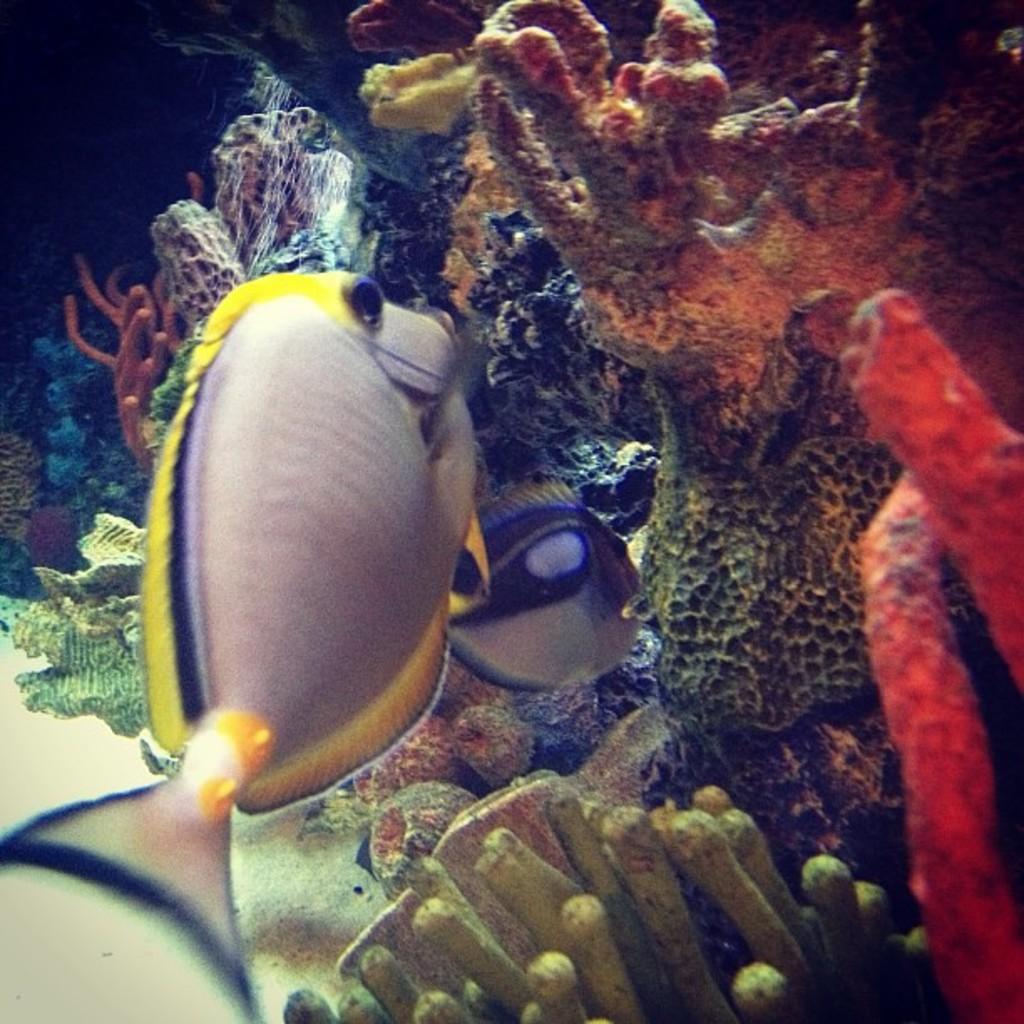In one or two sentences, can you explain what this image depicts? As we can see in the image there are fishes, plant and water. 